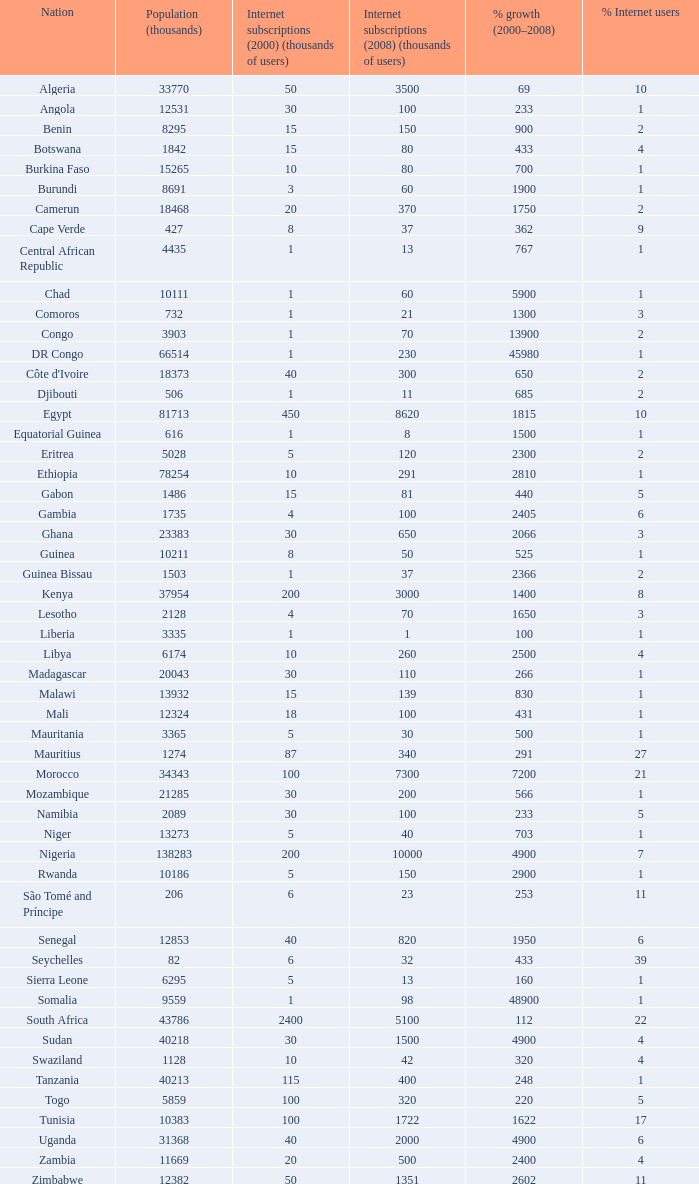Name the total number of percentage growth 2000-2008 of uganda? 1.0. 